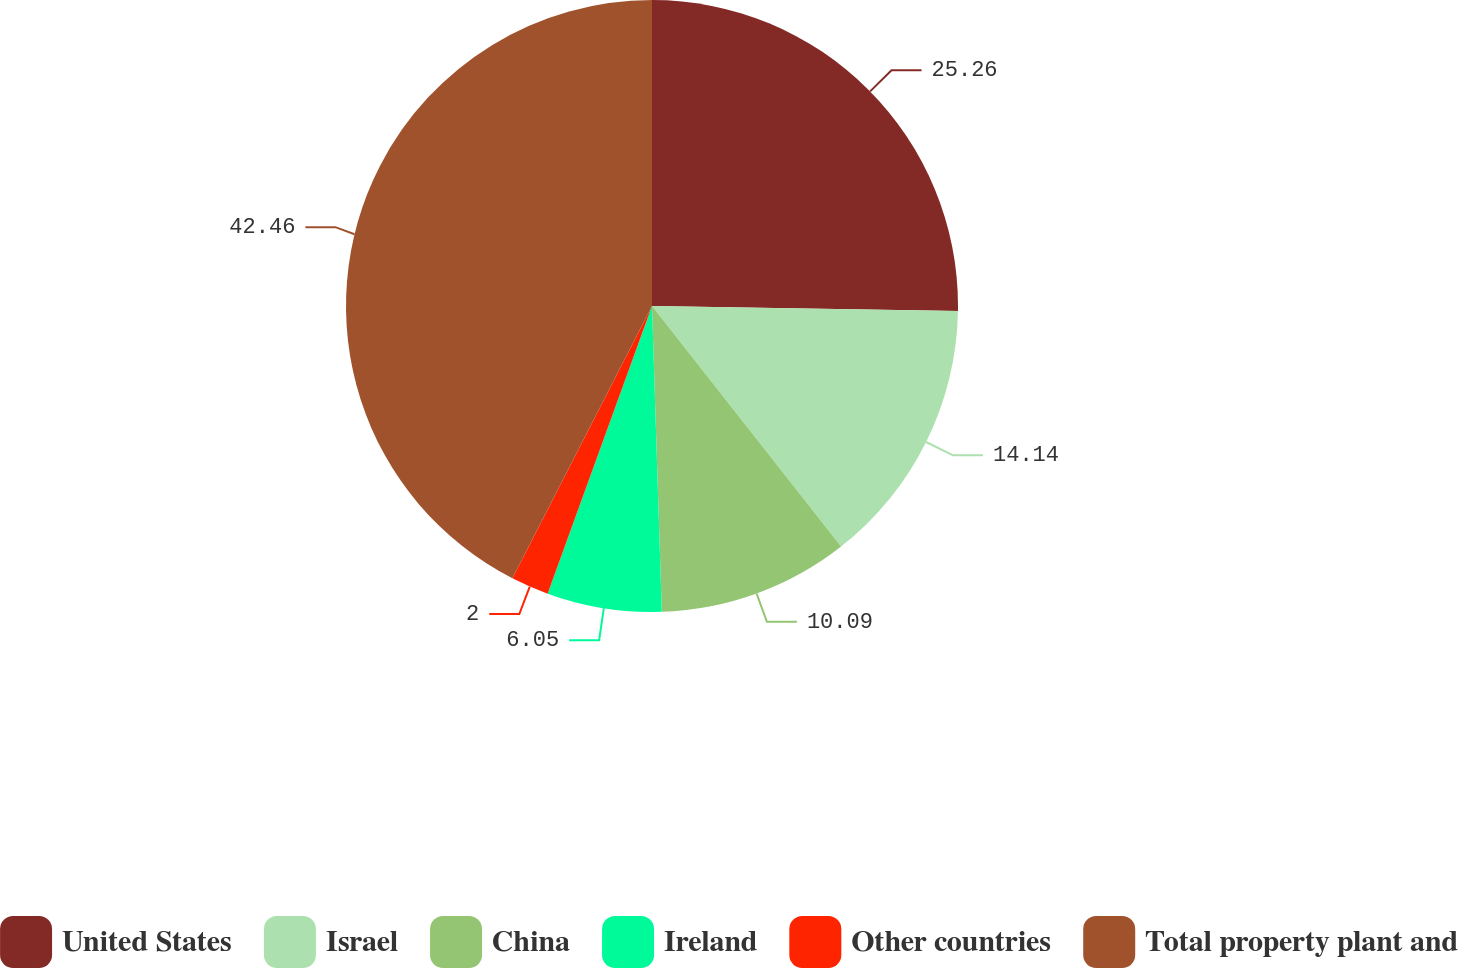<chart> <loc_0><loc_0><loc_500><loc_500><pie_chart><fcel>United States<fcel>Israel<fcel>China<fcel>Ireland<fcel>Other countries<fcel>Total property plant and<nl><fcel>25.26%<fcel>14.14%<fcel>10.09%<fcel>6.05%<fcel>2.0%<fcel>42.46%<nl></chart> 